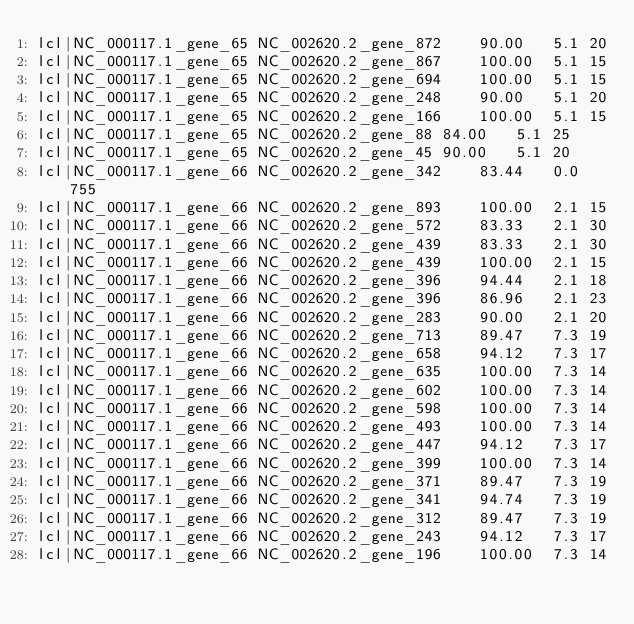<code> <loc_0><loc_0><loc_500><loc_500><_SQL_>lcl|NC_000117.1_gene_65	NC_002620.2_gene_872	90.00	5.1	20
lcl|NC_000117.1_gene_65	NC_002620.2_gene_867	100.00	5.1	15
lcl|NC_000117.1_gene_65	NC_002620.2_gene_694	100.00	5.1	15
lcl|NC_000117.1_gene_65	NC_002620.2_gene_248	90.00	5.1	20
lcl|NC_000117.1_gene_65	NC_002620.2_gene_166	100.00	5.1	15
lcl|NC_000117.1_gene_65	NC_002620.2_gene_88	84.00	5.1	25
lcl|NC_000117.1_gene_65	NC_002620.2_gene_45	90.00	5.1	20
lcl|NC_000117.1_gene_66	NC_002620.2_gene_342	83.44	0.0	755
lcl|NC_000117.1_gene_66	NC_002620.2_gene_893	100.00	2.1	15
lcl|NC_000117.1_gene_66	NC_002620.2_gene_572	83.33	2.1	30
lcl|NC_000117.1_gene_66	NC_002620.2_gene_439	83.33	2.1	30
lcl|NC_000117.1_gene_66	NC_002620.2_gene_439	100.00	2.1	15
lcl|NC_000117.1_gene_66	NC_002620.2_gene_396	94.44	2.1	18
lcl|NC_000117.1_gene_66	NC_002620.2_gene_396	86.96	2.1	23
lcl|NC_000117.1_gene_66	NC_002620.2_gene_283	90.00	2.1	20
lcl|NC_000117.1_gene_66	NC_002620.2_gene_713	89.47	7.3	19
lcl|NC_000117.1_gene_66	NC_002620.2_gene_658	94.12	7.3	17
lcl|NC_000117.1_gene_66	NC_002620.2_gene_635	100.00	7.3	14
lcl|NC_000117.1_gene_66	NC_002620.2_gene_602	100.00	7.3	14
lcl|NC_000117.1_gene_66	NC_002620.2_gene_598	100.00	7.3	14
lcl|NC_000117.1_gene_66	NC_002620.2_gene_493	100.00	7.3	14
lcl|NC_000117.1_gene_66	NC_002620.2_gene_447	94.12	7.3	17
lcl|NC_000117.1_gene_66	NC_002620.2_gene_399	100.00	7.3	14
lcl|NC_000117.1_gene_66	NC_002620.2_gene_371	89.47	7.3	19
lcl|NC_000117.1_gene_66	NC_002620.2_gene_341	94.74	7.3	19
lcl|NC_000117.1_gene_66	NC_002620.2_gene_312	89.47	7.3	19
lcl|NC_000117.1_gene_66	NC_002620.2_gene_243	94.12	7.3	17
lcl|NC_000117.1_gene_66	NC_002620.2_gene_196	100.00	7.3	14</code> 